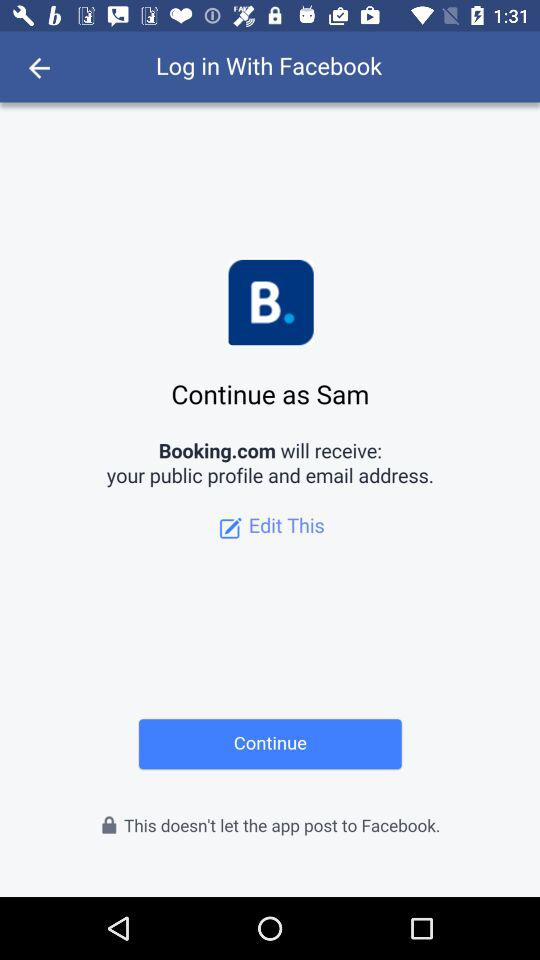What application is asking for permission? The application is "Booking.com". 